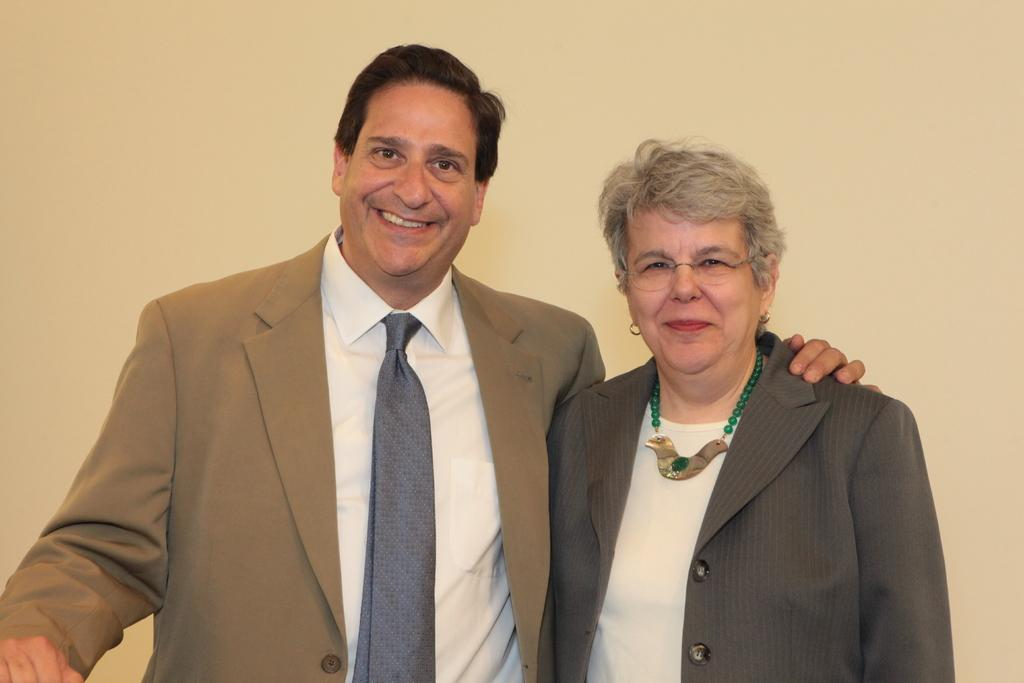How many people are in the picture? There are two people in the picture. What are the people doing in the picture? The people are standing in the picture. What are the people wearing in the picture? The people are wearing blazers in the picture. What expressions do the people have in the picture? The people are smiling in the picture. What is the color of the backdrop in the picture? The backdrop is cream in color. What type of alarm can be heard going off in the background of the picture? There is no alarm present in the picture, and therefore no such sound can be heard. 